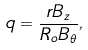<formula> <loc_0><loc_0><loc_500><loc_500>q = \frac { r B _ { z } } { R _ { o } B _ { \theta } } ,</formula> 